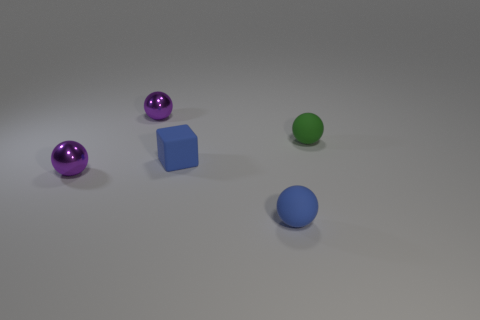What mood or atmosphere does the composition of these objects evoke? The arrangement of the objects and the lighting create a calm and balanced atmosphere. The cool color palette and the simple geometric shapes provide a minimalist aesthetic that is both soothing and orderly. 